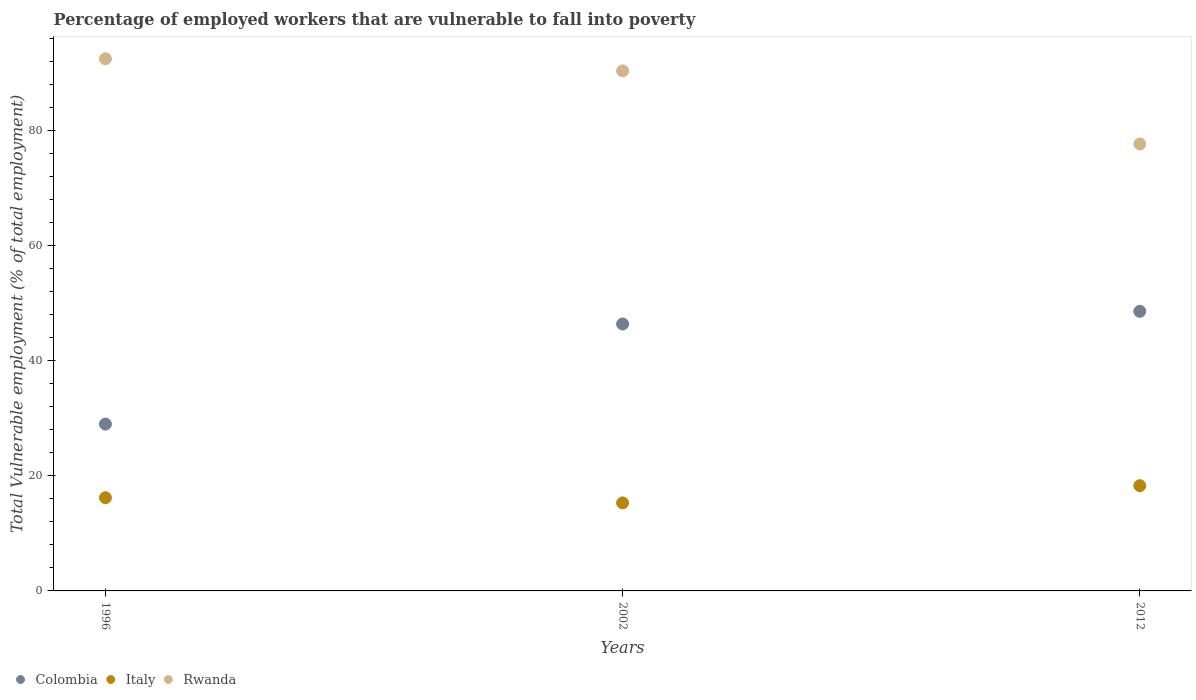How many different coloured dotlines are there?
Make the answer very short. 3. Is the number of dotlines equal to the number of legend labels?
Keep it short and to the point. Yes. What is the percentage of employed workers who are vulnerable to fall into poverty in Rwanda in 2012?
Make the answer very short. 77.7. Across all years, what is the maximum percentage of employed workers who are vulnerable to fall into poverty in Rwanda?
Offer a terse response. 92.5. Across all years, what is the minimum percentage of employed workers who are vulnerable to fall into poverty in Rwanda?
Give a very brief answer. 77.7. In which year was the percentage of employed workers who are vulnerable to fall into poverty in Italy minimum?
Offer a terse response. 2002. What is the total percentage of employed workers who are vulnerable to fall into poverty in Rwanda in the graph?
Provide a short and direct response. 260.6. What is the difference between the percentage of employed workers who are vulnerable to fall into poverty in Colombia in 2002 and that in 2012?
Offer a very short reply. -2.2. What is the difference between the percentage of employed workers who are vulnerable to fall into poverty in Italy in 2002 and the percentage of employed workers who are vulnerable to fall into poverty in Rwanda in 2012?
Your response must be concise. -62.4. What is the average percentage of employed workers who are vulnerable to fall into poverty in Italy per year?
Provide a short and direct response. 16.6. In the year 1996, what is the difference between the percentage of employed workers who are vulnerable to fall into poverty in Colombia and percentage of employed workers who are vulnerable to fall into poverty in Italy?
Ensure brevity in your answer.  12.8. What is the ratio of the percentage of employed workers who are vulnerable to fall into poverty in Rwanda in 1996 to that in 2002?
Keep it short and to the point. 1.02. Is the percentage of employed workers who are vulnerable to fall into poverty in Colombia in 1996 less than that in 2002?
Provide a short and direct response. Yes. Is the difference between the percentage of employed workers who are vulnerable to fall into poverty in Colombia in 1996 and 2002 greater than the difference between the percentage of employed workers who are vulnerable to fall into poverty in Italy in 1996 and 2002?
Offer a very short reply. No. What is the difference between the highest and the second highest percentage of employed workers who are vulnerable to fall into poverty in Italy?
Provide a succinct answer. 2.1. What is the difference between the highest and the lowest percentage of employed workers who are vulnerable to fall into poverty in Italy?
Provide a short and direct response. 3. Is the sum of the percentage of employed workers who are vulnerable to fall into poverty in Italy in 2002 and 2012 greater than the maximum percentage of employed workers who are vulnerable to fall into poverty in Rwanda across all years?
Offer a terse response. No. Is it the case that in every year, the sum of the percentage of employed workers who are vulnerable to fall into poverty in Rwanda and percentage of employed workers who are vulnerable to fall into poverty in Colombia  is greater than the percentage of employed workers who are vulnerable to fall into poverty in Italy?
Provide a succinct answer. Yes. Is the percentage of employed workers who are vulnerable to fall into poverty in Italy strictly less than the percentage of employed workers who are vulnerable to fall into poverty in Colombia over the years?
Your response must be concise. Yes. How many years are there in the graph?
Your response must be concise. 3. What is the difference between two consecutive major ticks on the Y-axis?
Provide a succinct answer. 20. What is the title of the graph?
Give a very brief answer. Percentage of employed workers that are vulnerable to fall into poverty. What is the label or title of the Y-axis?
Keep it short and to the point. Total Vulnerable employment (% of total employment). What is the Total Vulnerable employment (% of total employment) of Colombia in 1996?
Offer a very short reply. 29. What is the Total Vulnerable employment (% of total employment) in Italy in 1996?
Provide a succinct answer. 16.2. What is the Total Vulnerable employment (% of total employment) in Rwanda in 1996?
Keep it short and to the point. 92.5. What is the Total Vulnerable employment (% of total employment) of Colombia in 2002?
Your answer should be very brief. 46.4. What is the Total Vulnerable employment (% of total employment) of Italy in 2002?
Offer a very short reply. 15.3. What is the Total Vulnerable employment (% of total employment) in Rwanda in 2002?
Give a very brief answer. 90.4. What is the Total Vulnerable employment (% of total employment) of Colombia in 2012?
Your answer should be compact. 48.6. What is the Total Vulnerable employment (% of total employment) of Italy in 2012?
Provide a short and direct response. 18.3. What is the Total Vulnerable employment (% of total employment) of Rwanda in 2012?
Your response must be concise. 77.7. Across all years, what is the maximum Total Vulnerable employment (% of total employment) of Colombia?
Your response must be concise. 48.6. Across all years, what is the maximum Total Vulnerable employment (% of total employment) in Italy?
Your answer should be very brief. 18.3. Across all years, what is the maximum Total Vulnerable employment (% of total employment) in Rwanda?
Offer a terse response. 92.5. Across all years, what is the minimum Total Vulnerable employment (% of total employment) in Italy?
Give a very brief answer. 15.3. Across all years, what is the minimum Total Vulnerable employment (% of total employment) in Rwanda?
Ensure brevity in your answer.  77.7. What is the total Total Vulnerable employment (% of total employment) of Colombia in the graph?
Give a very brief answer. 124. What is the total Total Vulnerable employment (% of total employment) of Italy in the graph?
Make the answer very short. 49.8. What is the total Total Vulnerable employment (% of total employment) of Rwanda in the graph?
Provide a short and direct response. 260.6. What is the difference between the Total Vulnerable employment (% of total employment) of Colombia in 1996 and that in 2002?
Give a very brief answer. -17.4. What is the difference between the Total Vulnerable employment (% of total employment) in Colombia in 1996 and that in 2012?
Give a very brief answer. -19.6. What is the difference between the Total Vulnerable employment (% of total employment) in Italy in 1996 and that in 2012?
Your answer should be compact. -2.1. What is the difference between the Total Vulnerable employment (% of total employment) of Rwanda in 1996 and that in 2012?
Provide a succinct answer. 14.8. What is the difference between the Total Vulnerable employment (% of total employment) in Colombia in 2002 and that in 2012?
Your answer should be compact. -2.2. What is the difference between the Total Vulnerable employment (% of total employment) of Italy in 2002 and that in 2012?
Your answer should be very brief. -3. What is the difference between the Total Vulnerable employment (% of total employment) of Rwanda in 2002 and that in 2012?
Provide a short and direct response. 12.7. What is the difference between the Total Vulnerable employment (% of total employment) of Colombia in 1996 and the Total Vulnerable employment (% of total employment) of Rwanda in 2002?
Your response must be concise. -61.4. What is the difference between the Total Vulnerable employment (% of total employment) of Italy in 1996 and the Total Vulnerable employment (% of total employment) of Rwanda in 2002?
Keep it short and to the point. -74.2. What is the difference between the Total Vulnerable employment (% of total employment) of Colombia in 1996 and the Total Vulnerable employment (% of total employment) of Rwanda in 2012?
Your answer should be compact. -48.7. What is the difference between the Total Vulnerable employment (% of total employment) of Italy in 1996 and the Total Vulnerable employment (% of total employment) of Rwanda in 2012?
Your answer should be compact. -61.5. What is the difference between the Total Vulnerable employment (% of total employment) of Colombia in 2002 and the Total Vulnerable employment (% of total employment) of Italy in 2012?
Offer a terse response. 28.1. What is the difference between the Total Vulnerable employment (% of total employment) in Colombia in 2002 and the Total Vulnerable employment (% of total employment) in Rwanda in 2012?
Make the answer very short. -31.3. What is the difference between the Total Vulnerable employment (% of total employment) in Italy in 2002 and the Total Vulnerable employment (% of total employment) in Rwanda in 2012?
Offer a terse response. -62.4. What is the average Total Vulnerable employment (% of total employment) in Colombia per year?
Offer a very short reply. 41.33. What is the average Total Vulnerable employment (% of total employment) of Italy per year?
Provide a succinct answer. 16.6. What is the average Total Vulnerable employment (% of total employment) in Rwanda per year?
Keep it short and to the point. 86.87. In the year 1996, what is the difference between the Total Vulnerable employment (% of total employment) in Colombia and Total Vulnerable employment (% of total employment) in Rwanda?
Ensure brevity in your answer.  -63.5. In the year 1996, what is the difference between the Total Vulnerable employment (% of total employment) in Italy and Total Vulnerable employment (% of total employment) in Rwanda?
Offer a very short reply. -76.3. In the year 2002, what is the difference between the Total Vulnerable employment (% of total employment) of Colombia and Total Vulnerable employment (% of total employment) of Italy?
Provide a succinct answer. 31.1. In the year 2002, what is the difference between the Total Vulnerable employment (% of total employment) in Colombia and Total Vulnerable employment (% of total employment) in Rwanda?
Ensure brevity in your answer.  -44. In the year 2002, what is the difference between the Total Vulnerable employment (% of total employment) in Italy and Total Vulnerable employment (% of total employment) in Rwanda?
Your response must be concise. -75.1. In the year 2012, what is the difference between the Total Vulnerable employment (% of total employment) in Colombia and Total Vulnerable employment (% of total employment) in Italy?
Offer a terse response. 30.3. In the year 2012, what is the difference between the Total Vulnerable employment (% of total employment) of Colombia and Total Vulnerable employment (% of total employment) of Rwanda?
Offer a terse response. -29.1. In the year 2012, what is the difference between the Total Vulnerable employment (% of total employment) in Italy and Total Vulnerable employment (% of total employment) in Rwanda?
Your answer should be very brief. -59.4. What is the ratio of the Total Vulnerable employment (% of total employment) in Colombia in 1996 to that in 2002?
Make the answer very short. 0.62. What is the ratio of the Total Vulnerable employment (% of total employment) in Italy in 1996 to that in 2002?
Make the answer very short. 1.06. What is the ratio of the Total Vulnerable employment (% of total employment) in Rwanda in 1996 to that in 2002?
Ensure brevity in your answer.  1.02. What is the ratio of the Total Vulnerable employment (% of total employment) of Colombia in 1996 to that in 2012?
Provide a short and direct response. 0.6. What is the ratio of the Total Vulnerable employment (% of total employment) in Italy in 1996 to that in 2012?
Your answer should be compact. 0.89. What is the ratio of the Total Vulnerable employment (% of total employment) of Rwanda in 1996 to that in 2012?
Keep it short and to the point. 1.19. What is the ratio of the Total Vulnerable employment (% of total employment) in Colombia in 2002 to that in 2012?
Make the answer very short. 0.95. What is the ratio of the Total Vulnerable employment (% of total employment) in Italy in 2002 to that in 2012?
Your answer should be very brief. 0.84. What is the ratio of the Total Vulnerable employment (% of total employment) in Rwanda in 2002 to that in 2012?
Your answer should be compact. 1.16. What is the difference between the highest and the second highest Total Vulnerable employment (% of total employment) of Colombia?
Offer a very short reply. 2.2. What is the difference between the highest and the lowest Total Vulnerable employment (% of total employment) in Colombia?
Give a very brief answer. 19.6. What is the difference between the highest and the lowest Total Vulnerable employment (% of total employment) in Italy?
Ensure brevity in your answer.  3. What is the difference between the highest and the lowest Total Vulnerable employment (% of total employment) of Rwanda?
Keep it short and to the point. 14.8. 